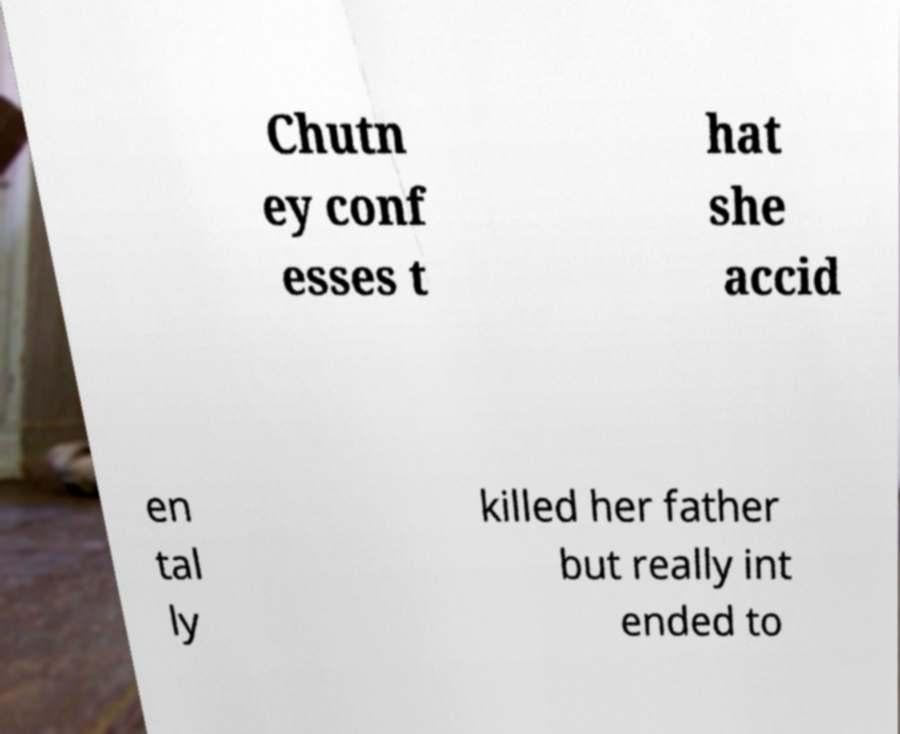I need the written content from this picture converted into text. Can you do that? Chutn ey conf esses t hat she accid en tal ly killed her father but really int ended to 